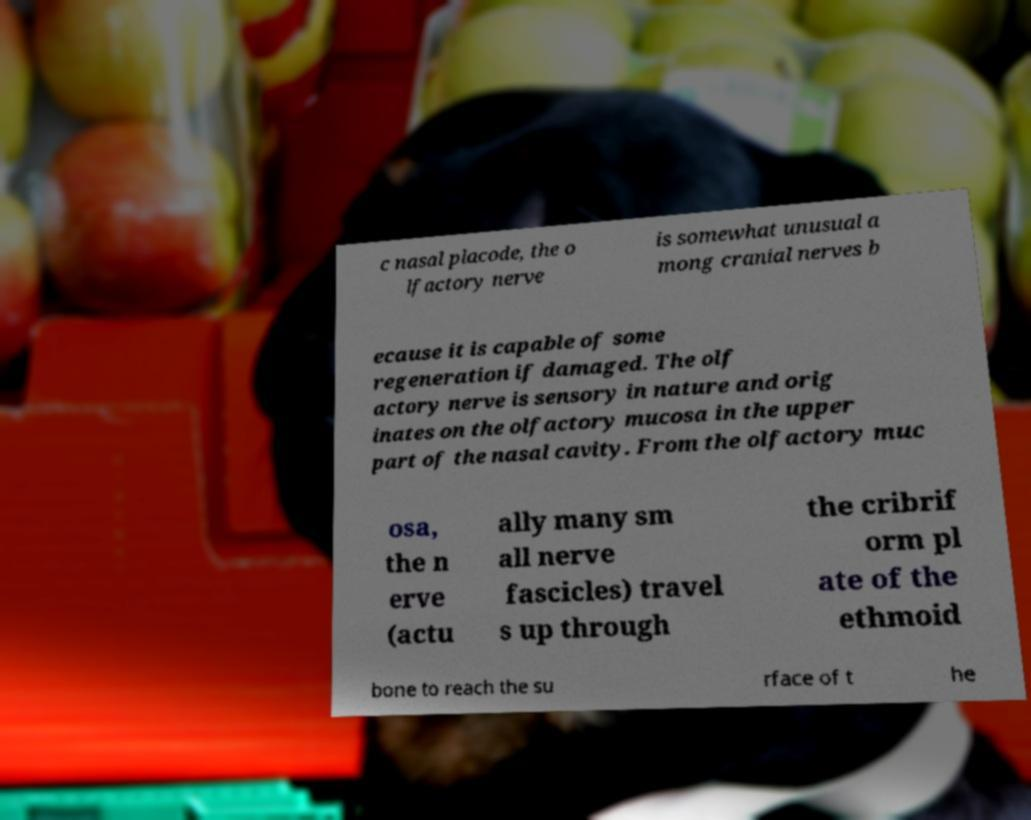Please read and relay the text visible in this image. What does it say? c nasal placode, the o lfactory nerve is somewhat unusual a mong cranial nerves b ecause it is capable of some regeneration if damaged. The olf actory nerve is sensory in nature and orig inates on the olfactory mucosa in the upper part of the nasal cavity. From the olfactory muc osa, the n erve (actu ally many sm all nerve fascicles) travel s up through the cribrif orm pl ate of the ethmoid bone to reach the su rface of t he 